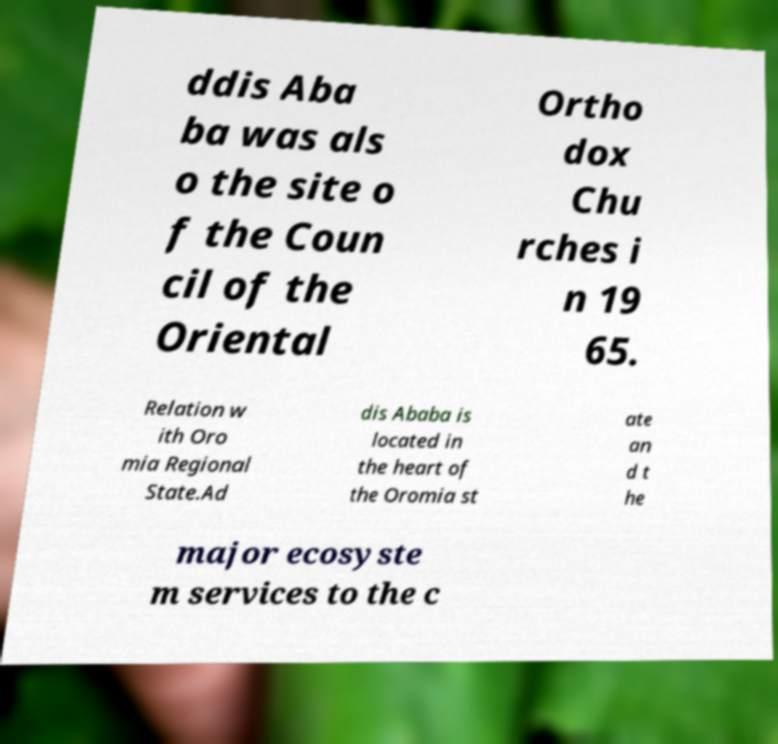Can you read and provide the text displayed in the image?This photo seems to have some interesting text. Can you extract and type it out for me? ddis Aba ba was als o the site o f the Coun cil of the Oriental Ortho dox Chu rches i n 19 65. Relation w ith Oro mia Regional State.Ad dis Ababa is located in the heart of the Oromia st ate an d t he major ecosyste m services to the c 